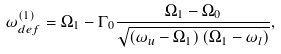<formula> <loc_0><loc_0><loc_500><loc_500>\omega _ { d e f } ^ { ( 1 ) } = \Omega _ { 1 } - \Gamma _ { 0 } \frac { \Omega _ { 1 } - \Omega _ { 0 } } { \sqrt { \left ( \omega _ { u } - \Omega _ { 1 } \right ) \left ( \Omega _ { 1 } - \omega _ { l } \right ) } } ,</formula> 